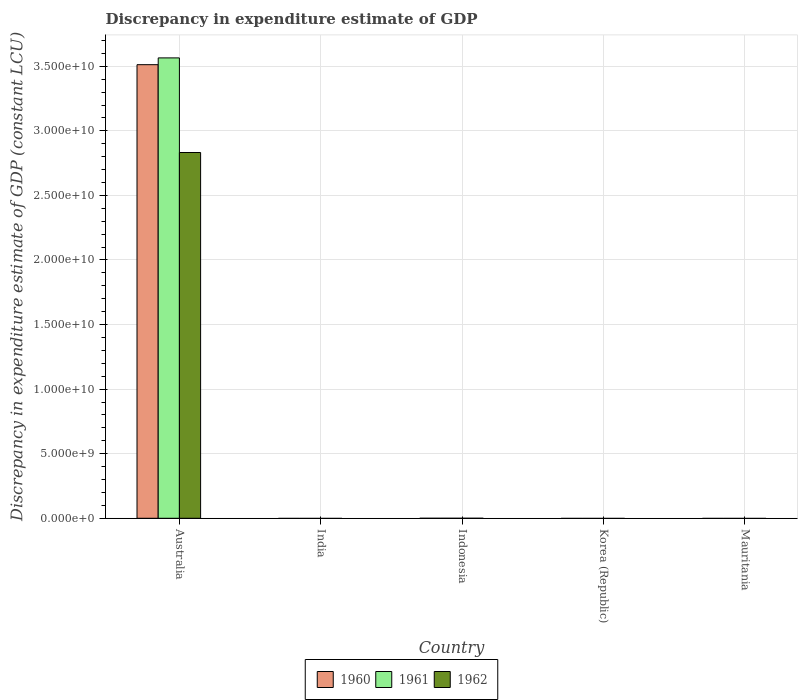How many different coloured bars are there?
Provide a succinct answer. 3. Are the number of bars per tick equal to the number of legend labels?
Provide a short and direct response. No. How many bars are there on the 5th tick from the left?
Your response must be concise. 0. How many bars are there on the 4th tick from the right?
Give a very brief answer. 0. What is the discrepancy in expenditure estimate of GDP in 1962 in Mauritania?
Keep it short and to the point. 0. Across all countries, what is the maximum discrepancy in expenditure estimate of GDP in 1961?
Offer a very short reply. 3.56e+1. Across all countries, what is the minimum discrepancy in expenditure estimate of GDP in 1961?
Your answer should be compact. 0. What is the total discrepancy in expenditure estimate of GDP in 1961 in the graph?
Make the answer very short. 3.56e+1. What is the average discrepancy in expenditure estimate of GDP in 1961 per country?
Provide a succinct answer. 7.13e+09. What is the difference between the discrepancy in expenditure estimate of GDP of/in 1962 and discrepancy in expenditure estimate of GDP of/in 1960 in Australia?
Your response must be concise. -6.80e+09. In how many countries, is the discrepancy in expenditure estimate of GDP in 1961 greater than 11000000000 LCU?
Ensure brevity in your answer.  1. What is the difference between the highest and the lowest discrepancy in expenditure estimate of GDP in 1962?
Your answer should be compact. 2.83e+1. In how many countries, is the discrepancy in expenditure estimate of GDP in 1960 greater than the average discrepancy in expenditure estimate of GDP in 1960 taken over all countries?
Make the answer very short. 1. What is the difference between two consecutive major ticks on the Y-axis?
Provide a succinct answer. 5.00e+09. Are the values on the major ticks of Y-axis written in scientific E-notation?
Provide a short and direct response. Yes. Does the graph contain any zero values?
Offer a very short reply. Yes. Does the graph contain grids?
Your answer should be compact. Yes. How are the legend labels stacked?
Provide a short and direct response. Horizontal. What is the title of the graph?
Give a very brief answer. Discrepancy in expenditure estimate of GDP. Does "1964" appear as one of the legend labels in the graph?
Your response must be concise. No. What is the label or title of the X-axis?
Offer a very short reply. Country. What is the label or title of the Y-axis?
Provide a short and direct response. Discrepancy in expenditure estimate of GDP (constant LCU). What is the Discrepancy in expenditure estimate of GDP (constant LCU) in 1960 in Australia?
Offer a terse response. 3.51e+1. What is the Discrepancy in expenditure estimate of GDP (constant LCU) of 1961 in Australia?
Ensure brevity in your answer.  3.56e+1. What is the Discrepancy in expenditure estimate of GDP (constant LCU) of 1962 in Australia?
Give a very brief answer. 2.83e+1. What is the Discrepancy in expenditure estimate of GDP (constant LCU) of 1960 in India?
Your answer should be very brief. 0. What is the Discrepancy in expenditure estimate of GDP (constant LCU) of 1961 in India?
Give a very brief answer. 0. Across all countries, what is the maximum Discrepancy in expenditure estimate of GDP (constant LCU) of 1960?
Make the answer very short. 3.51e+1. Across all countries, what is the maximum Discrepancy in expenditure estimate of GDP (constant LCU) of 1961?
Provide a succinct answer. 3.56e+1. Across all countries, what is the maximum Discrepancy in expenditure estimate of GDP (constant LCU) of 1962?
Offer a terse response. 2.83e+1. Across all countries, what is the minimum Discrepancy in expenditure estimate of GDP (constant LCU) of 1960?
Your answer should be very brief. 0. What is the total Discrepancy in expenditure estimate of GDP (constant LCU) of 1960 in the graph?
Give a very brief answer. 3.51e+1. What is the total Discrepancy in expenditure estimate of GDP (constant LCU) in 1961 in the graph?
Your answer should be very brief. 3.56e+1. What is the total Discrepancy in expenditure estimate of GDP (constant LCU) of 1962 in the graph?
Your response must be concise. 2.83e+1. What is the average Discrepancy in expenditure estimate of GDP (constant LCU) of 1960 per country?
Provide a short and direct response. 7.02e+09. What is the average Discrepancy in expenditure estimate of GDP (constant LCU) of 1961 per country?
Your response must be concise. 7.13e+09. What is the average Discrepancy in expenditure estimate of GDP (constant LCU) of 1962 per country?
Your response must be concise. 5.66e+09. What is the difference between the Discrepancy in expenditure estimate of GDP (constant LCU) in 1960 and Discrepancy in expenditure estimate of GDP (constant LCU) in 1961 in Australia?
Your response must be concise. -5.25e+08. What is the difference between the Discrepancy in expenditure estimate of GDP (constant LCU) in 1960 and Discrepancy in expenditure estimate of GDP (constant LCU) in 1962 in Australia?
Keep it short and to the point. 6.80e+09. What is the difference between the Discrepancy in expenditure estimate of GDP (constant LCU) of 1961 and Discrepancy in expenditure estimate of GDP (constant LCU) of 1962 in Australia?
Give a very brief answer. 7.33e+09. What is the difference between the highest and the lowest Discrepancy in expenditure estimate of GDP (constant LCU) in 1960?
Provide a short and direct response. 3.51e+1. What is the difference between the highest and the lowest Discrepancy in expenditure estimate of GDP (constant LCU) of 1961?
Keep it short and to the point. 3.56e+1. What is the difference between the highest and the lowest Discrepancy in expenditure estimate of GDP (constant LCU) of 1962?
Provide a succinct answer. 2.83e+1. 